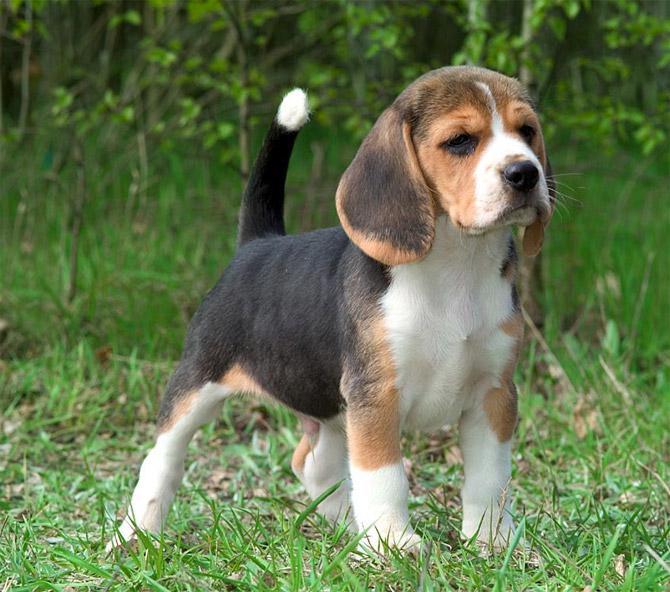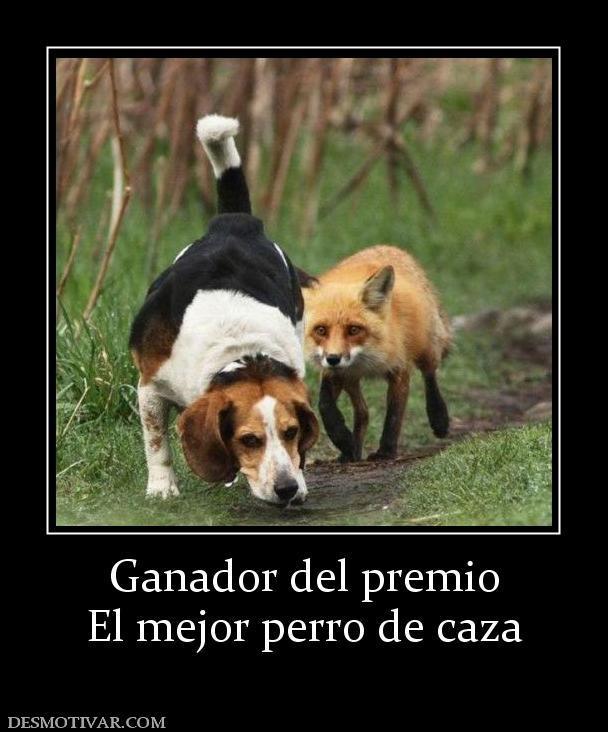The first image is the image on the left, the second image is the image on the right. Examine the images to the left and right. Is the description "dogs have ears flapping while they run" accurate? Answer yes or no. No. 